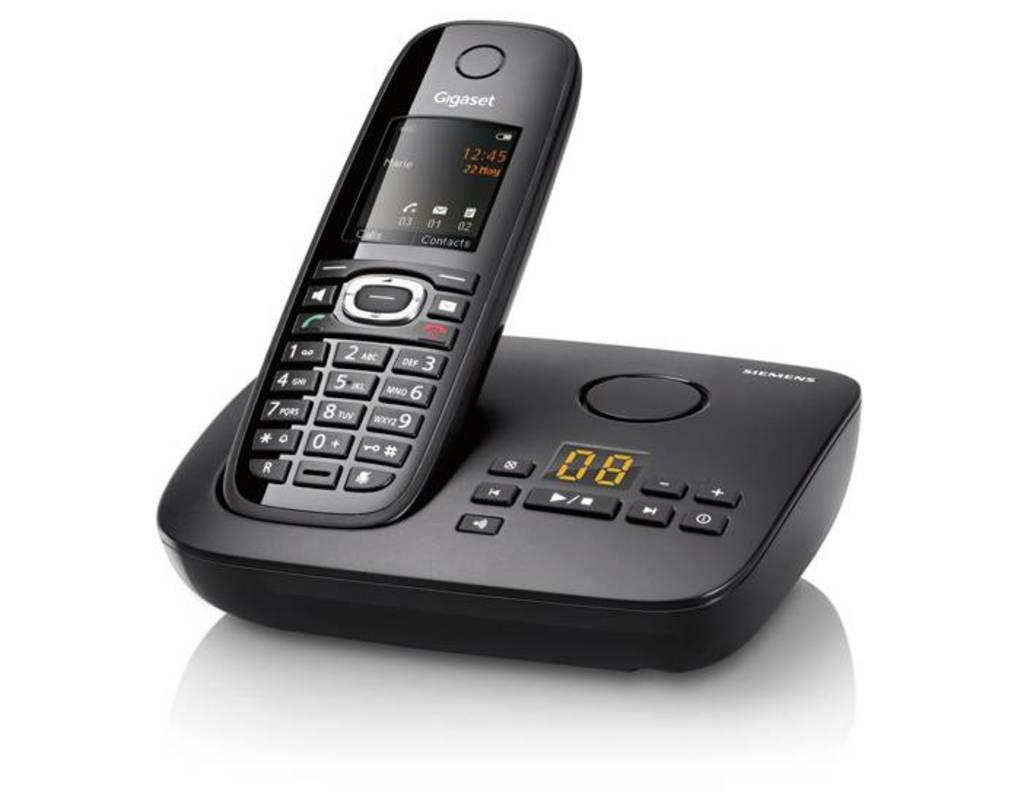<image>
Render a clear and concise summary of the photo. A Gigaset portable phone is sitting on its base. 